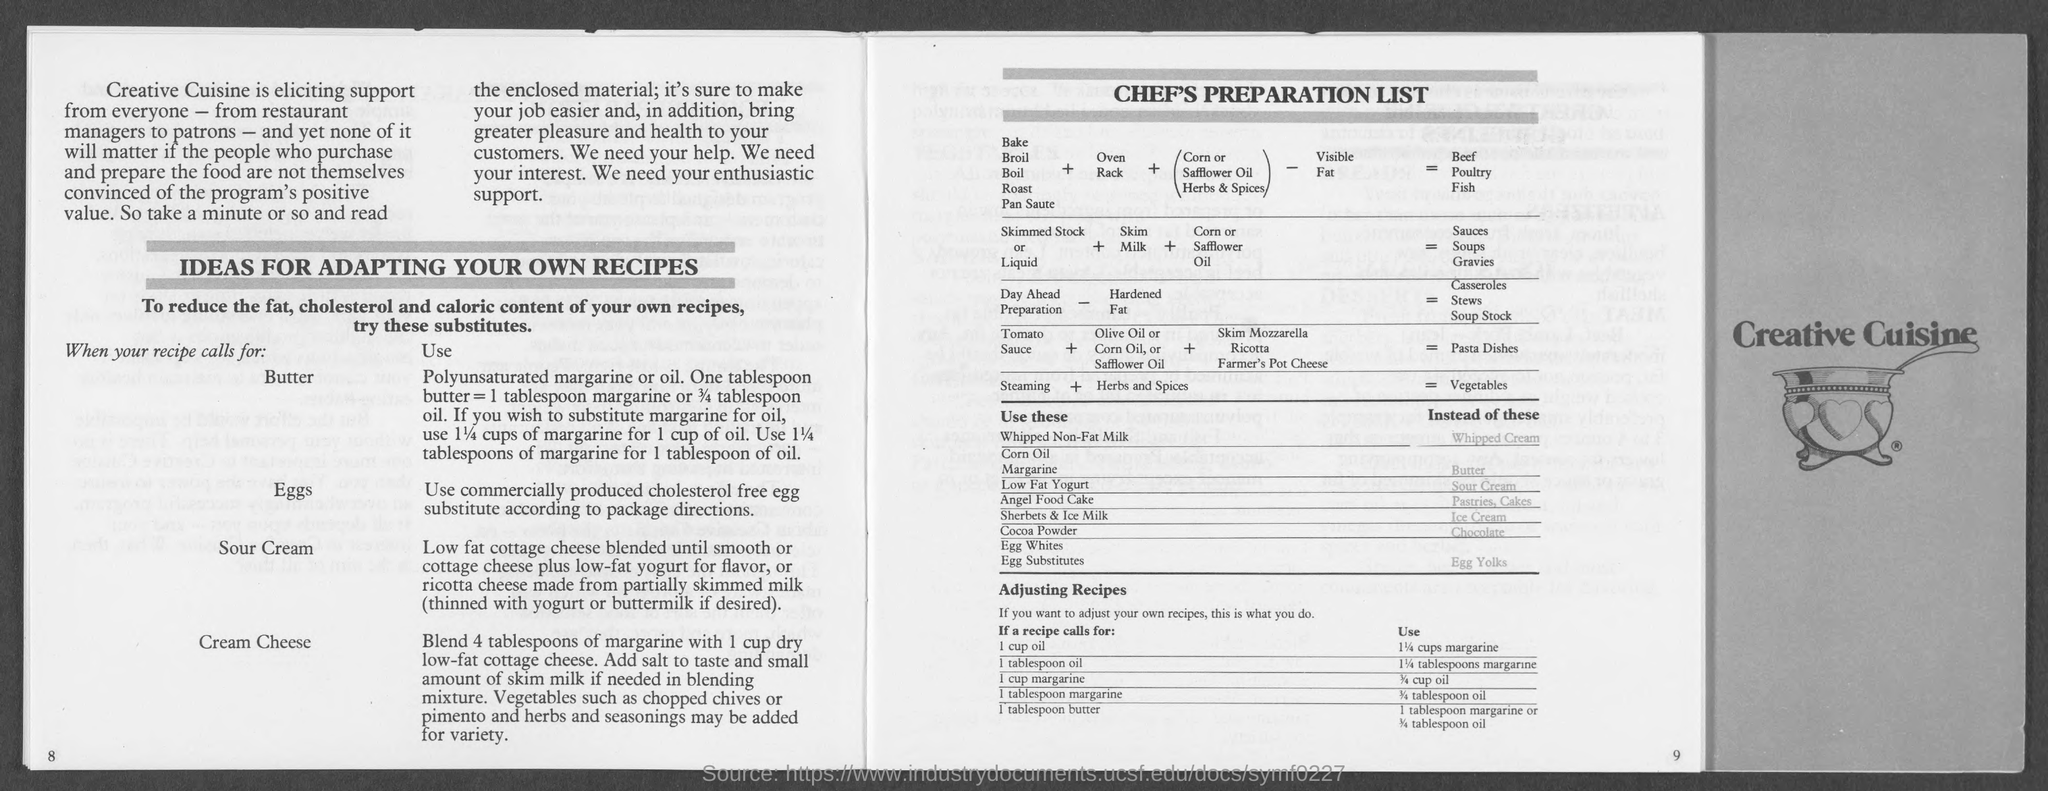Highlight a few significant elements in this photo. If a recipe calls for 1 cup of oil, 1 1/4 cups of margarine should be used instead. In terms of weight, one tablespoon of butter is equivalent to 1 tablespoon of margarine or 3/4 tablespoon of oil. 